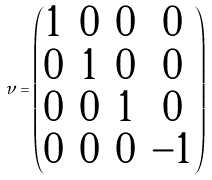Convert formula to latex. <formula><loc_0><loc_0><loc_500><loc_500>\nu = \left ( \begin{matrix} 1 & 0 & 0 & 0 \\ 0 & 1 & 0 & 0 \\ 0 & 0 & 1 & 0 \\ 0 & 0 & 0 & - 1 \end{matrix} \right )</formula> 